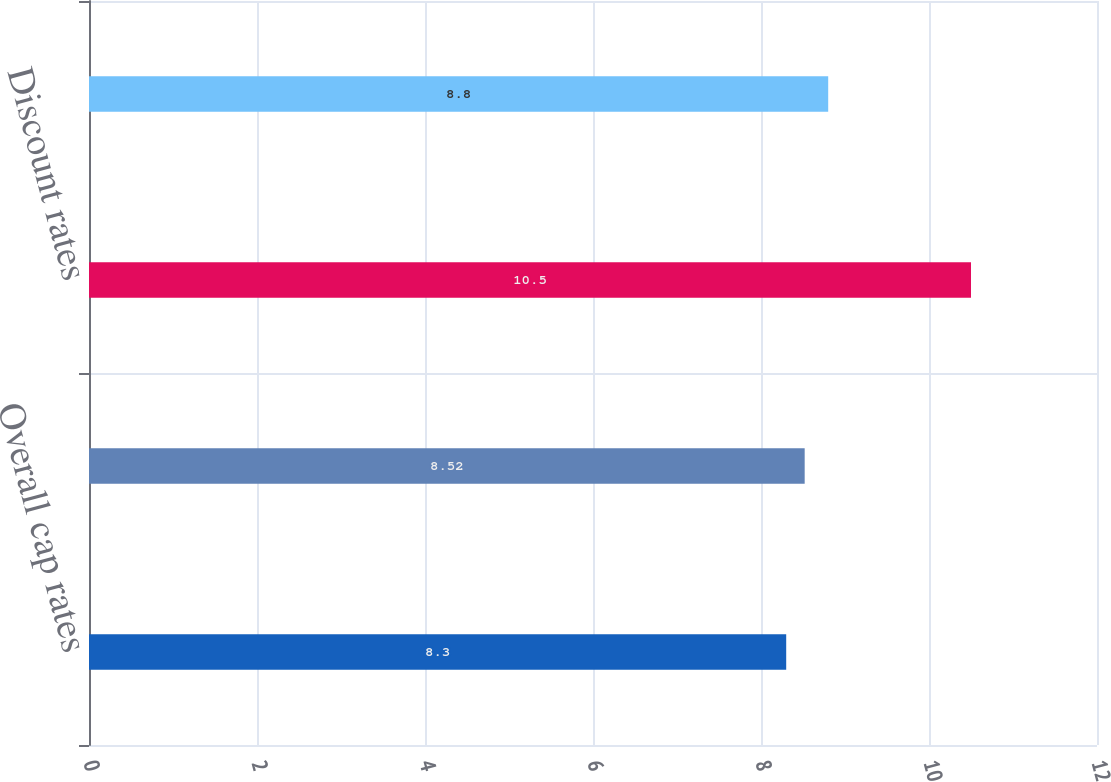<chart> <loc_0><loc_0><loc_500><loc_500><bar_chart><fcel>Overall cap rates<fcel>Rental growth rates<fcel>Discount rates<fcel>Terminal cap rates<nl><fcel>8.3<fcel>8.52<fcel>10.5<fcel>8.8<nl></chart> 